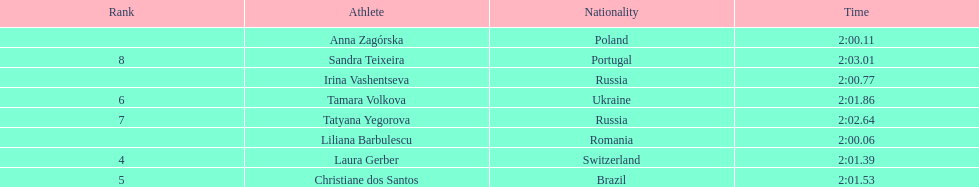Which south american country placed after irina vashentseva? Brazil. 